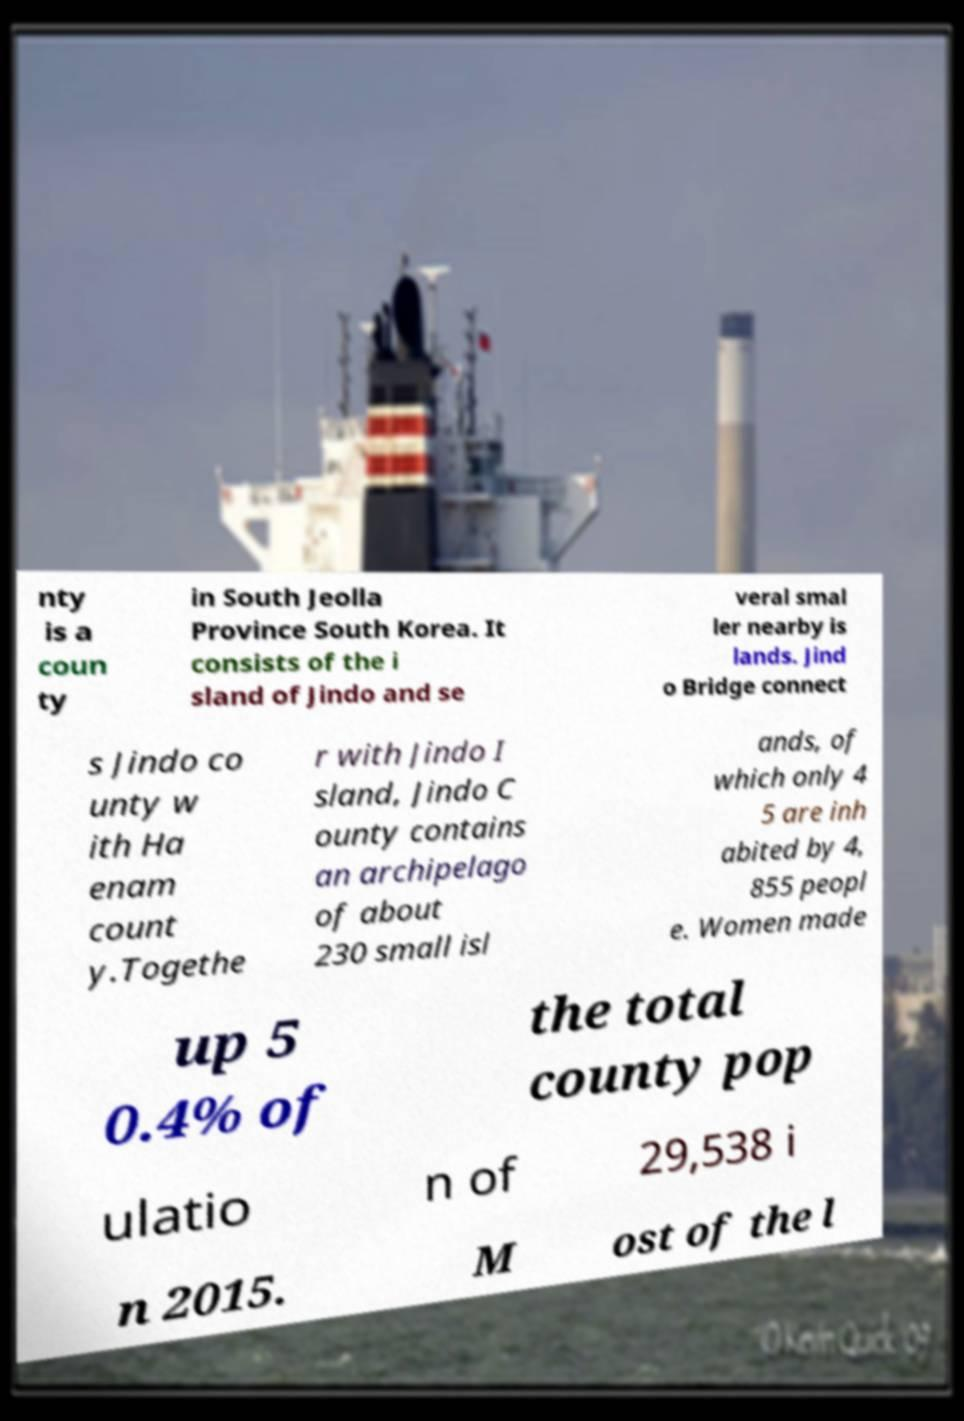There's text embedded in this image that I need extracted. Can you transcribe it verbatim? nty is a coun ty in South Jeolla Province South Korea. It consists of the i sland of Jindo and se veral smal ler nearby is lands. Jind o Bridge connect s Jindo co unty w ith Ha enam count y.Togethe r with Jindo I sland, Jindo C ounty contains an archipelago of about 230 small isl ands, of which only 4 5 are inh abited by 4, 855 peopl e. Women made up 5 0.4% of the total county pop ulatio n of 29,538 i n 2015. M ost of the l 